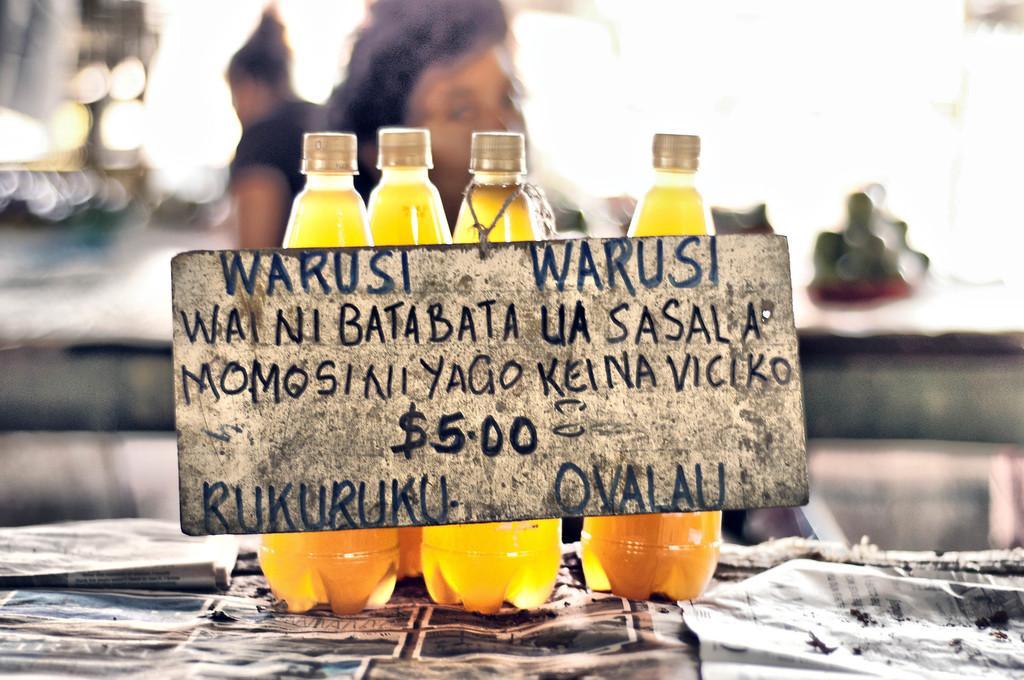Can you describe this image briefly? Here we can see four bottles present on a table with a board on them written something on it and behind the bottles we can see a couple of woman 